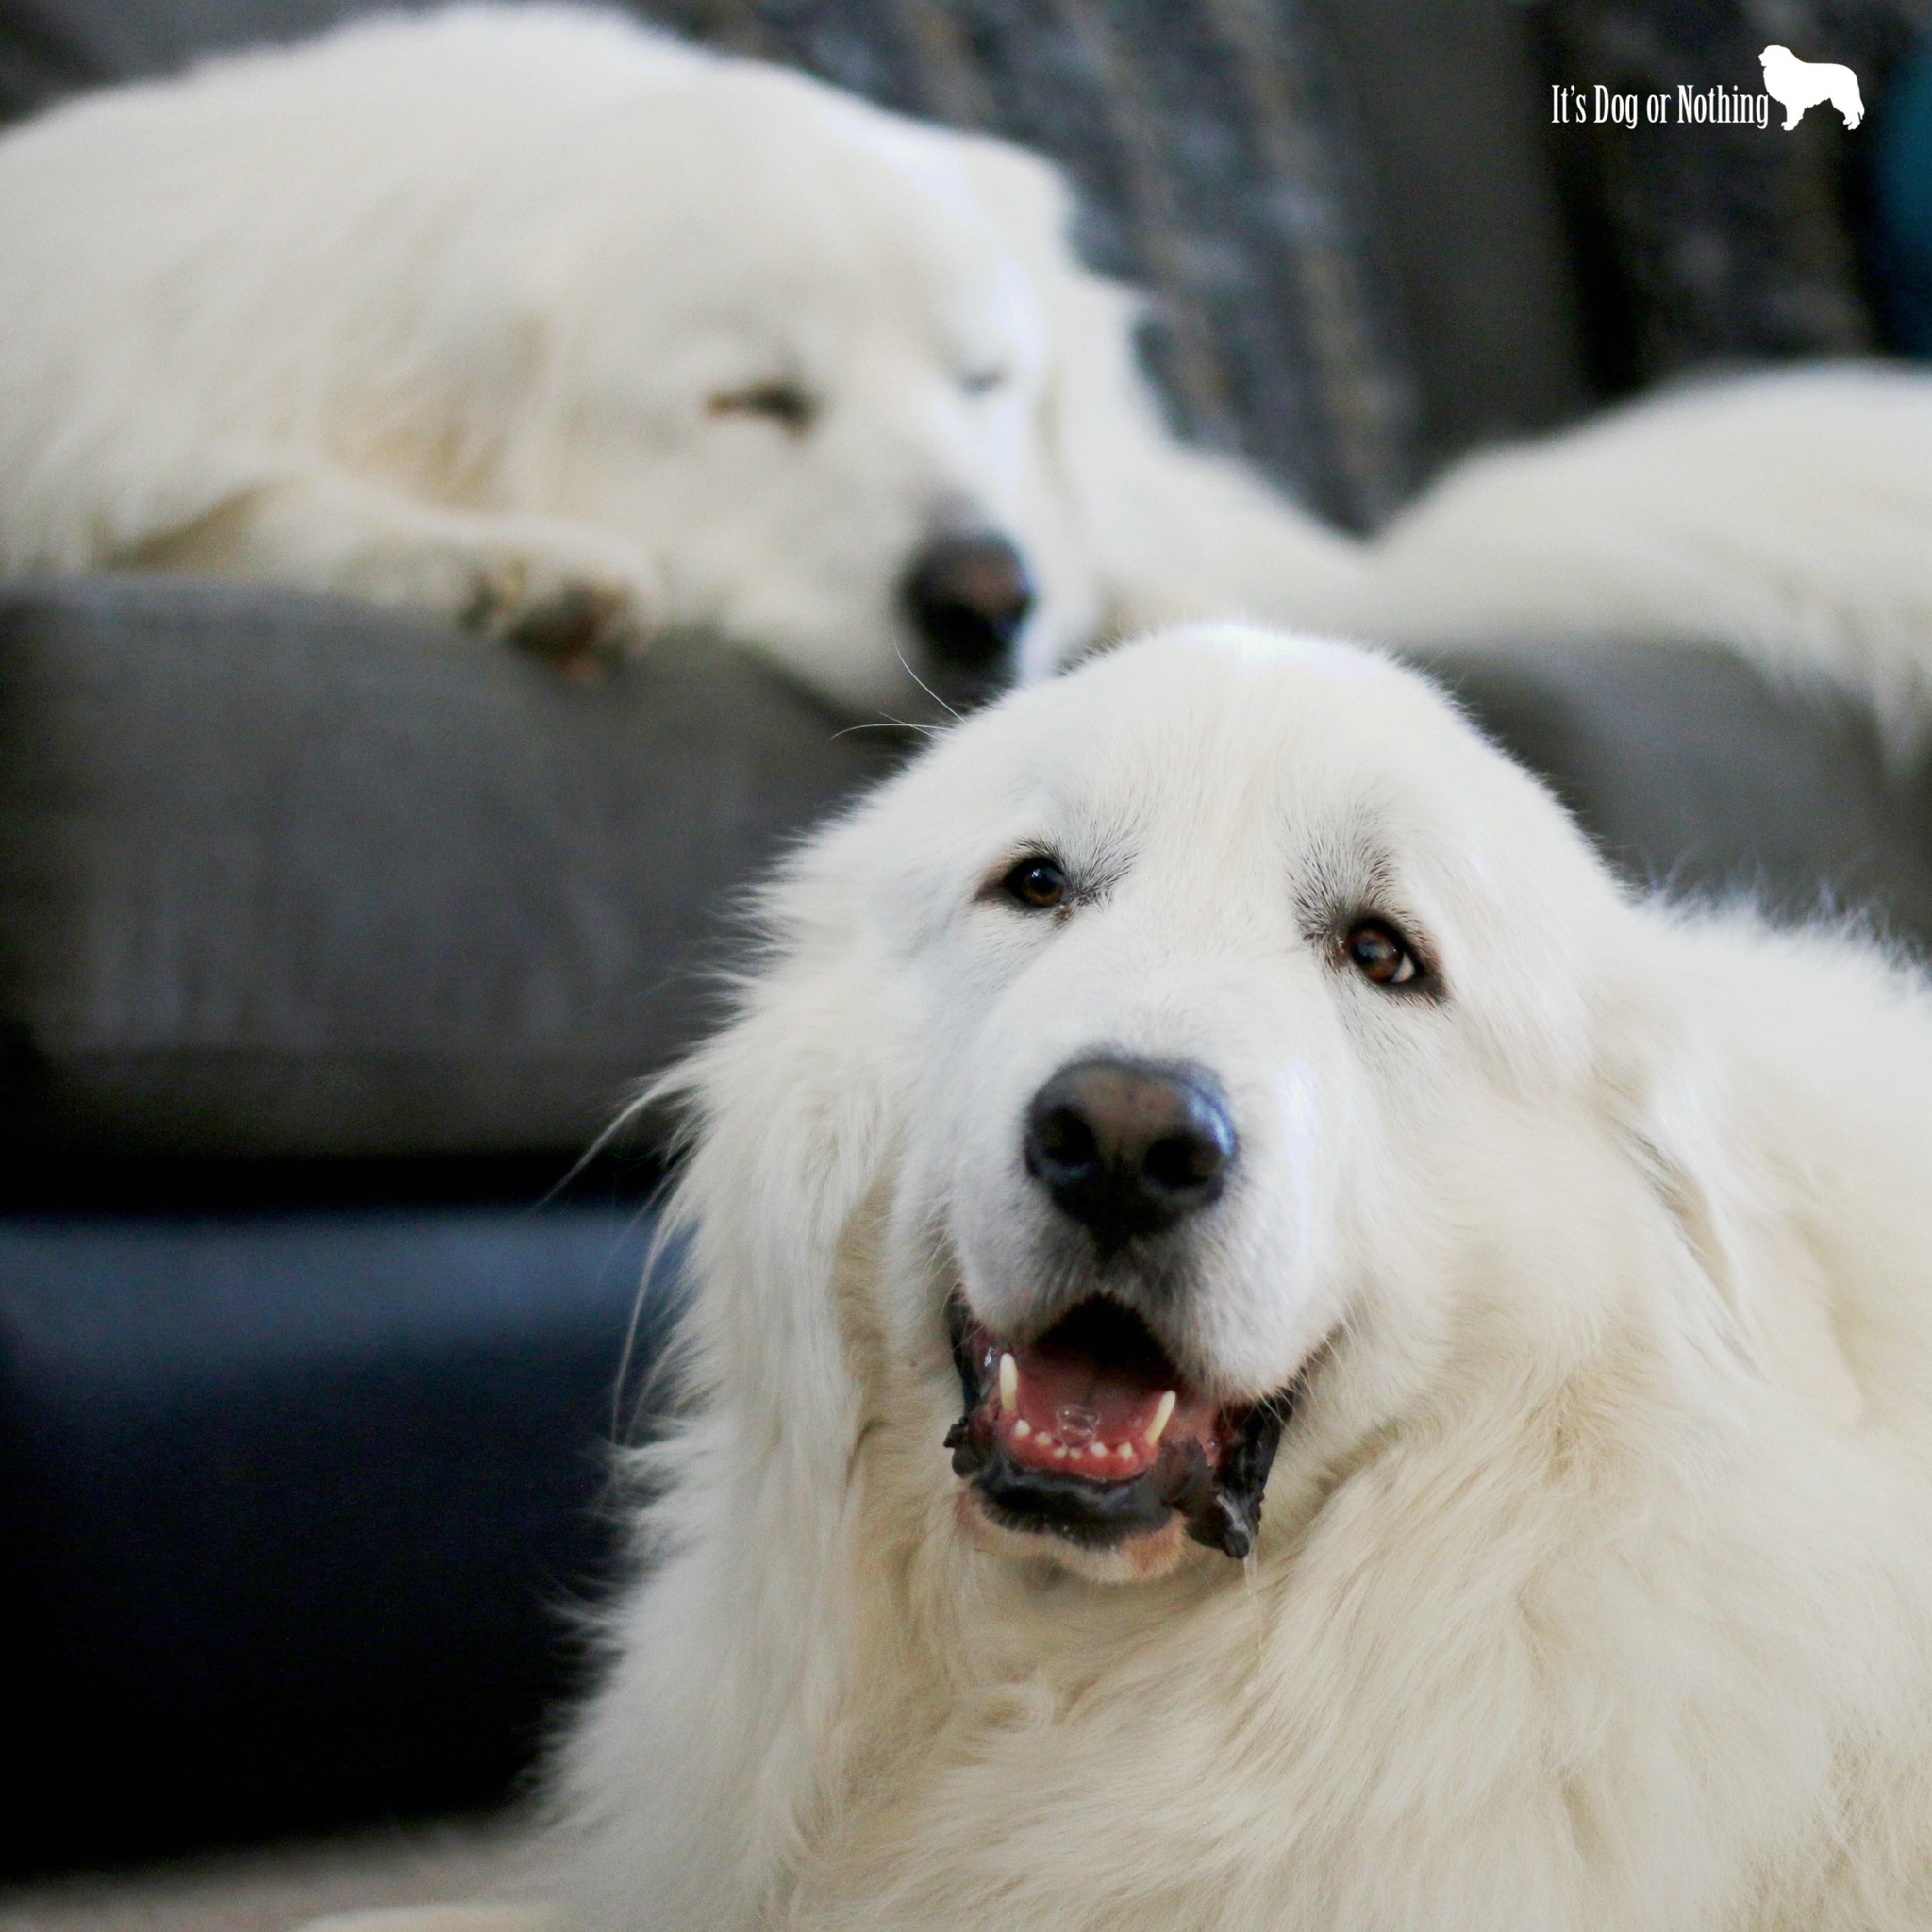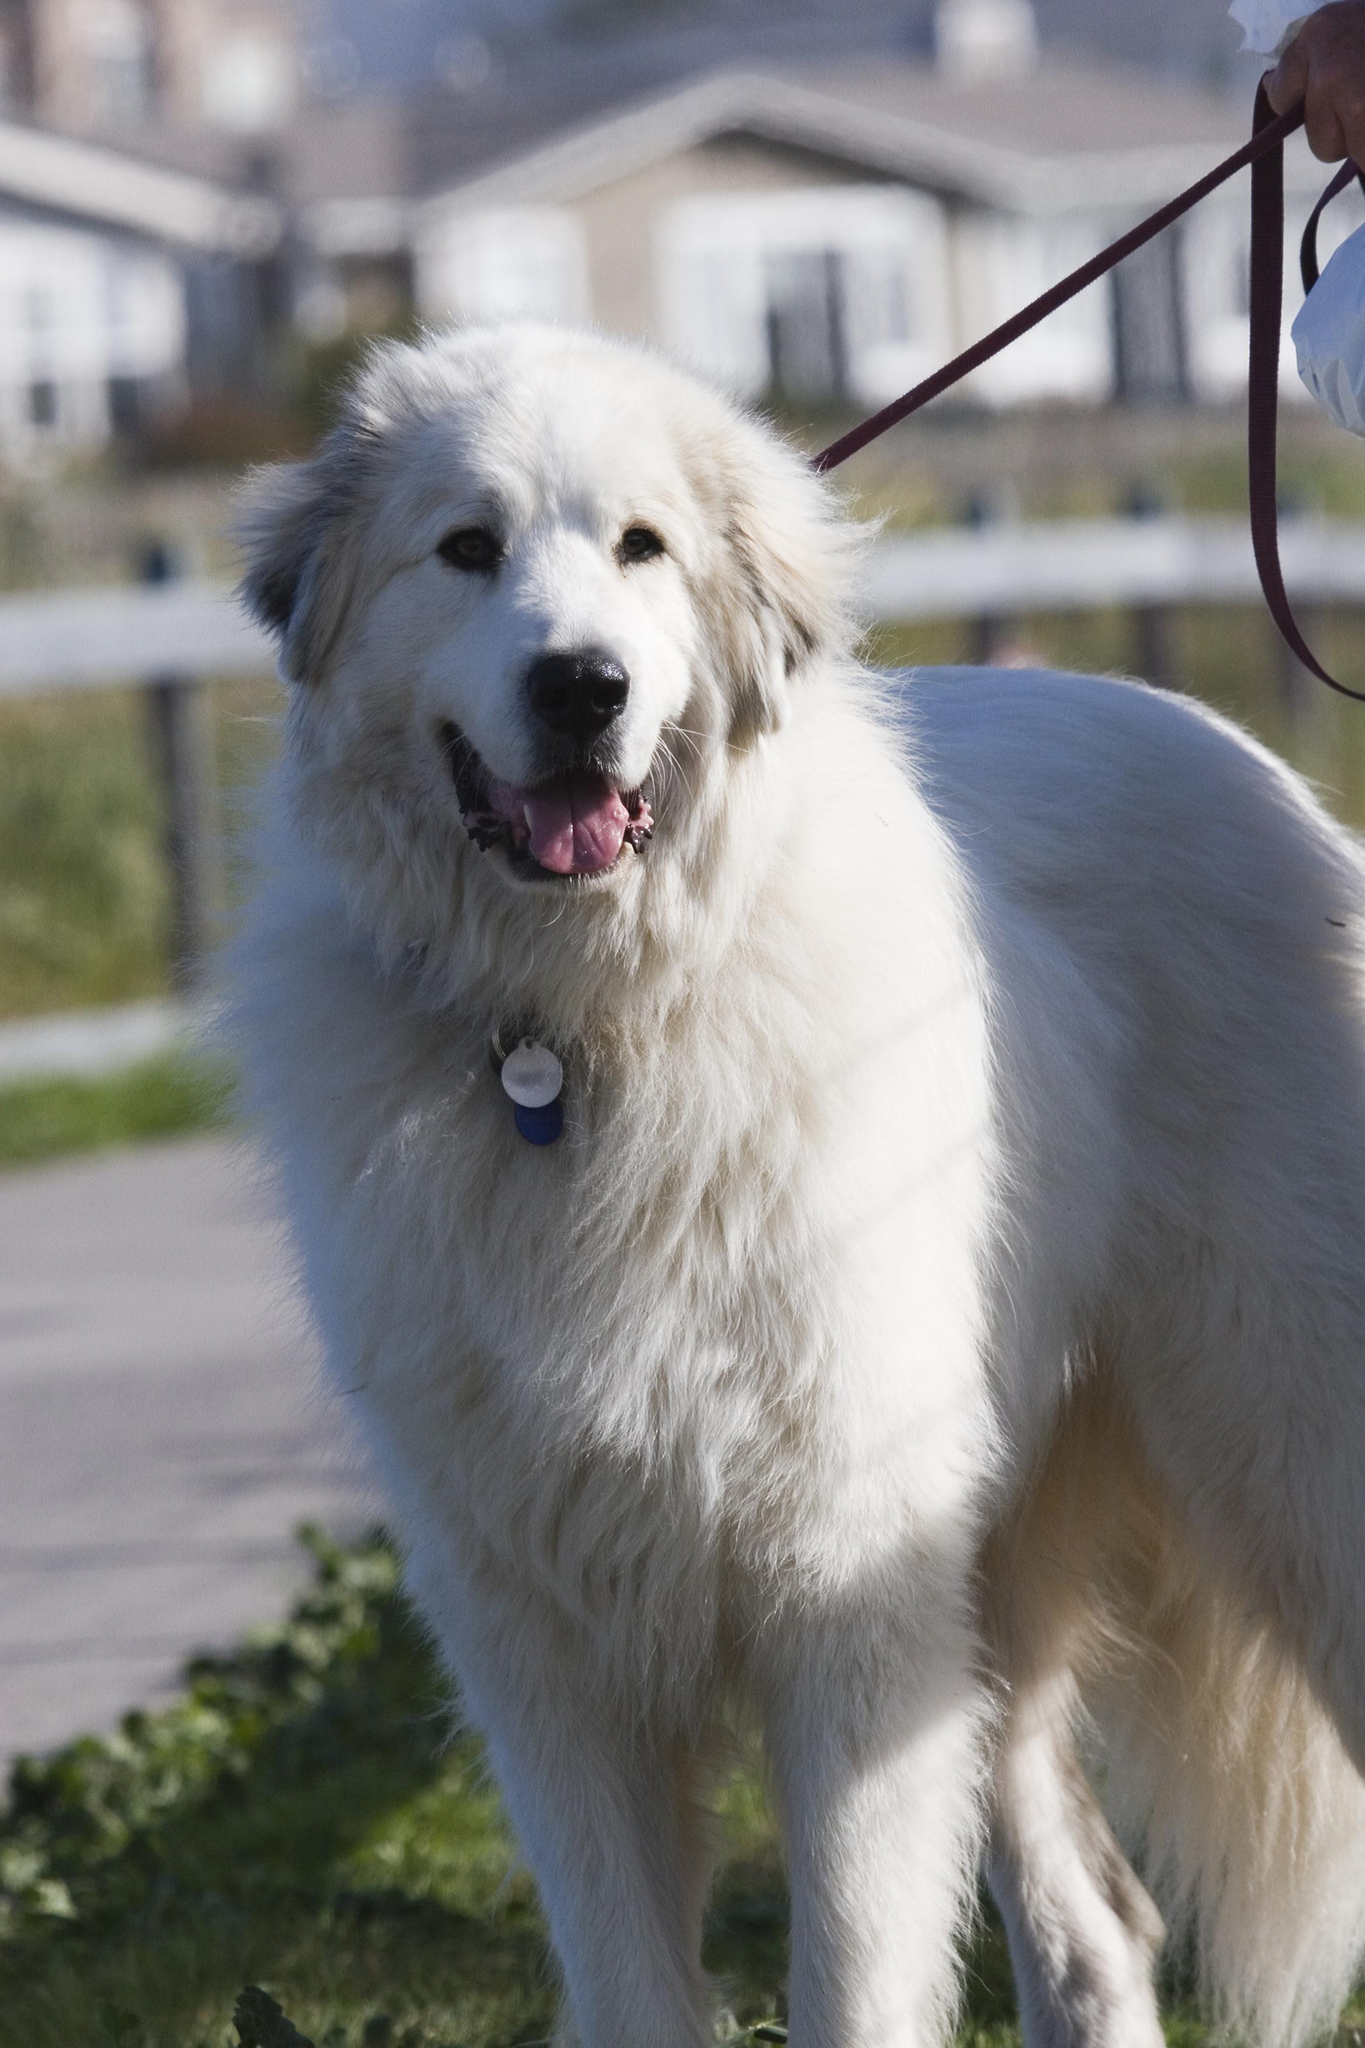The first image is the image on the left, the second image is the image on the right. Assess this claim about the two images: "One image contains more than one dog.". Correct or not? Answer yes or no. Yes. The first image is the image on the left, the second image is the image on the right. Considering the images on both sides, is "There are no more than two dogs." valid? Answer yes or no. No. 